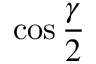<formula> <loc_0><loc_0><loc_500><loc_500>\cos { \frac { \gamma } { 2 } }</formula> 